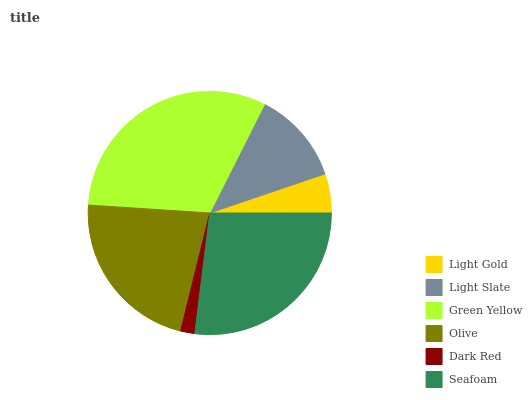Is Dark Red the minimum?
Answer yes or no. Yes. Is Green Yellow the maximum?
Answer yes or no. Yes. Is Light Slate the minimum?
Answer yes or no. No. Is Light Slate the maximum?
Answer yes or no. No. Is Light Slate greater than Light Gold?
Answer yes or no. Yes. Is Light Gold less than Light Slate?
Answer yes or no. Yes. Is Light Gold greater than Light Slate?
Answer yes or no. No. Is Light Slate less than Light Gold?
Answer yes or no. No. Is Olive the high median?
Answer yes or no. Yes. Is Light Slate the low median?
Answer yes or no. Yes. Is Green Yellow the high median?
Answer yes or no. No. Is Light Gold the low median?
Answer yes or no. No. 